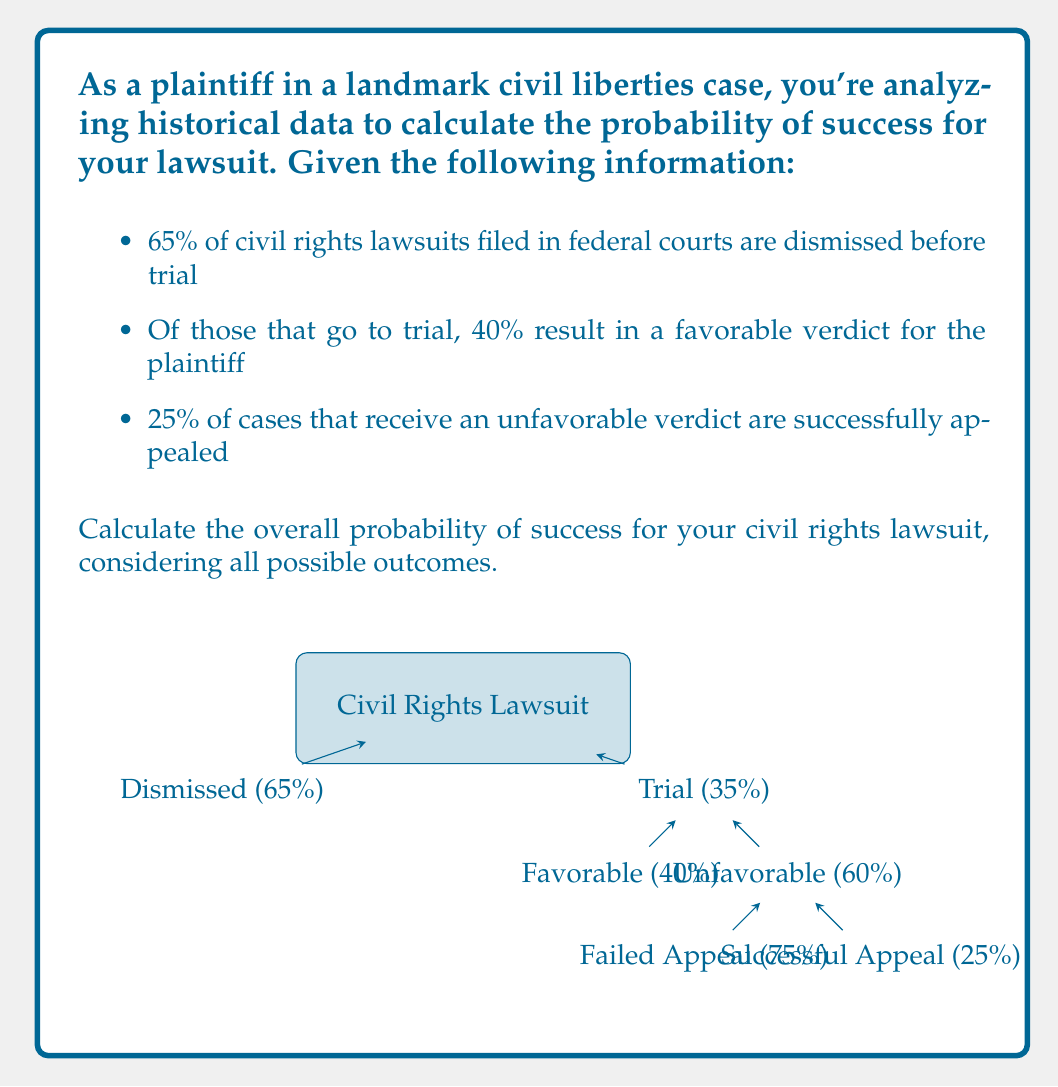Show me your answer to this math problem. Let's break this down step-by-step:

1) First, let's identify the possible successful outcomes:
   a) The case goes to trial and receives a favorable verdict
   b) The case goes to trial, receives an unfavorable verdict, but is successfully appealed

2) Let's calculate the probability of each outcome:

   a) Probability of going to trial and receiving a favorable verdict:
      $P(\text{Trial}) \cdot P(\text{Favorable Verdict})$
      $= 0.35 \cdot 0.40 = 0.14$ or 14%

   b) Probability of going to trial, receiving an unfavorable verdict, and successfully appealing:
      $P(\text{Trial}) \cdot P(\text{Unfavorable Verdict}) \cdot P(\text{Successful Appeal})$
      $= 0.35 \cdot 0.60 \cdot 0.25 = 0.0525$ or 5.25%

3) The overall probability of success is the sum of these two probabilities:

   $P(\text{Success}) = P(\text{Favorable Verdict}) + P(\text{Successful Appeal})$
   $= 0.14 + 0.0525 = 0.1925$

4) Convert to a percentage:
   $0.1925 \cdot 100\% = 19.25\%$

Therefore, the overall probability of success for your civil rights lawsuit is 19.25%.
Answer: 19.25% 